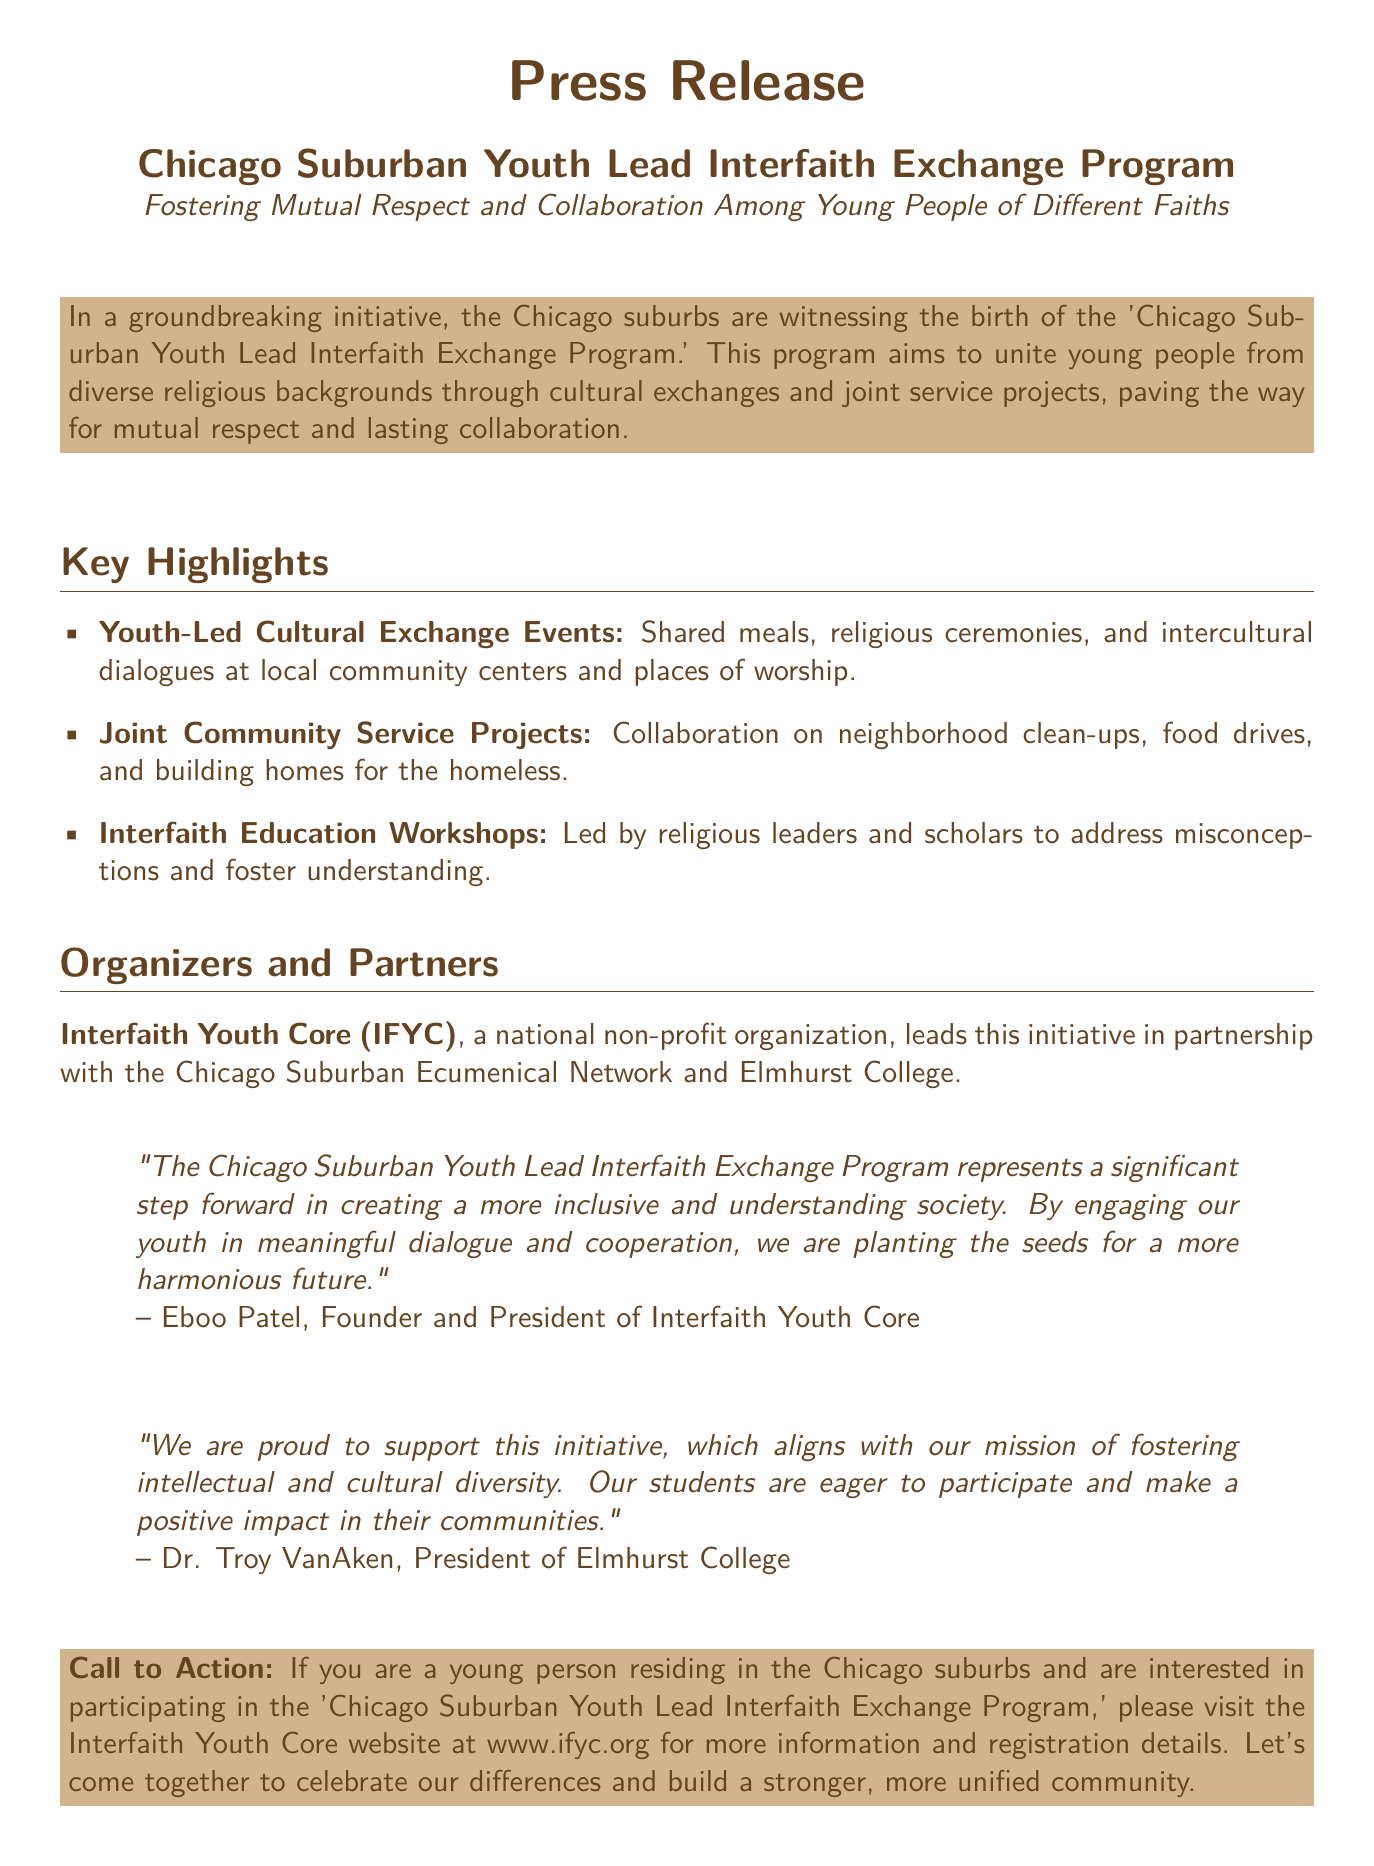What is the name of the program? The name of the program is explicitly stated in the document.
Answer: Chicago Suburban Youth Lead Interfaith Exchange Program Who leads the initiative? The document specifies that a particular organization is leading the initiative.
Answer: Interfaith Youth Core What types of events are included in the cultural exchange? The document lists various activities included in the cultural exchange events.
Answer: Shared meals, religious ceremonies, and intercultural dialogues What type of projects will the youth participate in together? The document outlines the nature of projects the youth will be involved in.
Answer: Joint community service projects Which college is a partner in this initiative? The document mentions a specific college that is partnering in the initiative.
Answer: Elmhurst College Who quoted their support for the initiative? The document includes quotes from notable individuals regarding the initiative.
Answer: Dr. Troy VanAken What is the website for more information? The document includes a call to action and specifies where to find more details.
Answer: www.ifyc.org What is the main goal of the program? The document indicates the overarching aim of the program.
Answer: Foster mutual respect and collaboration 